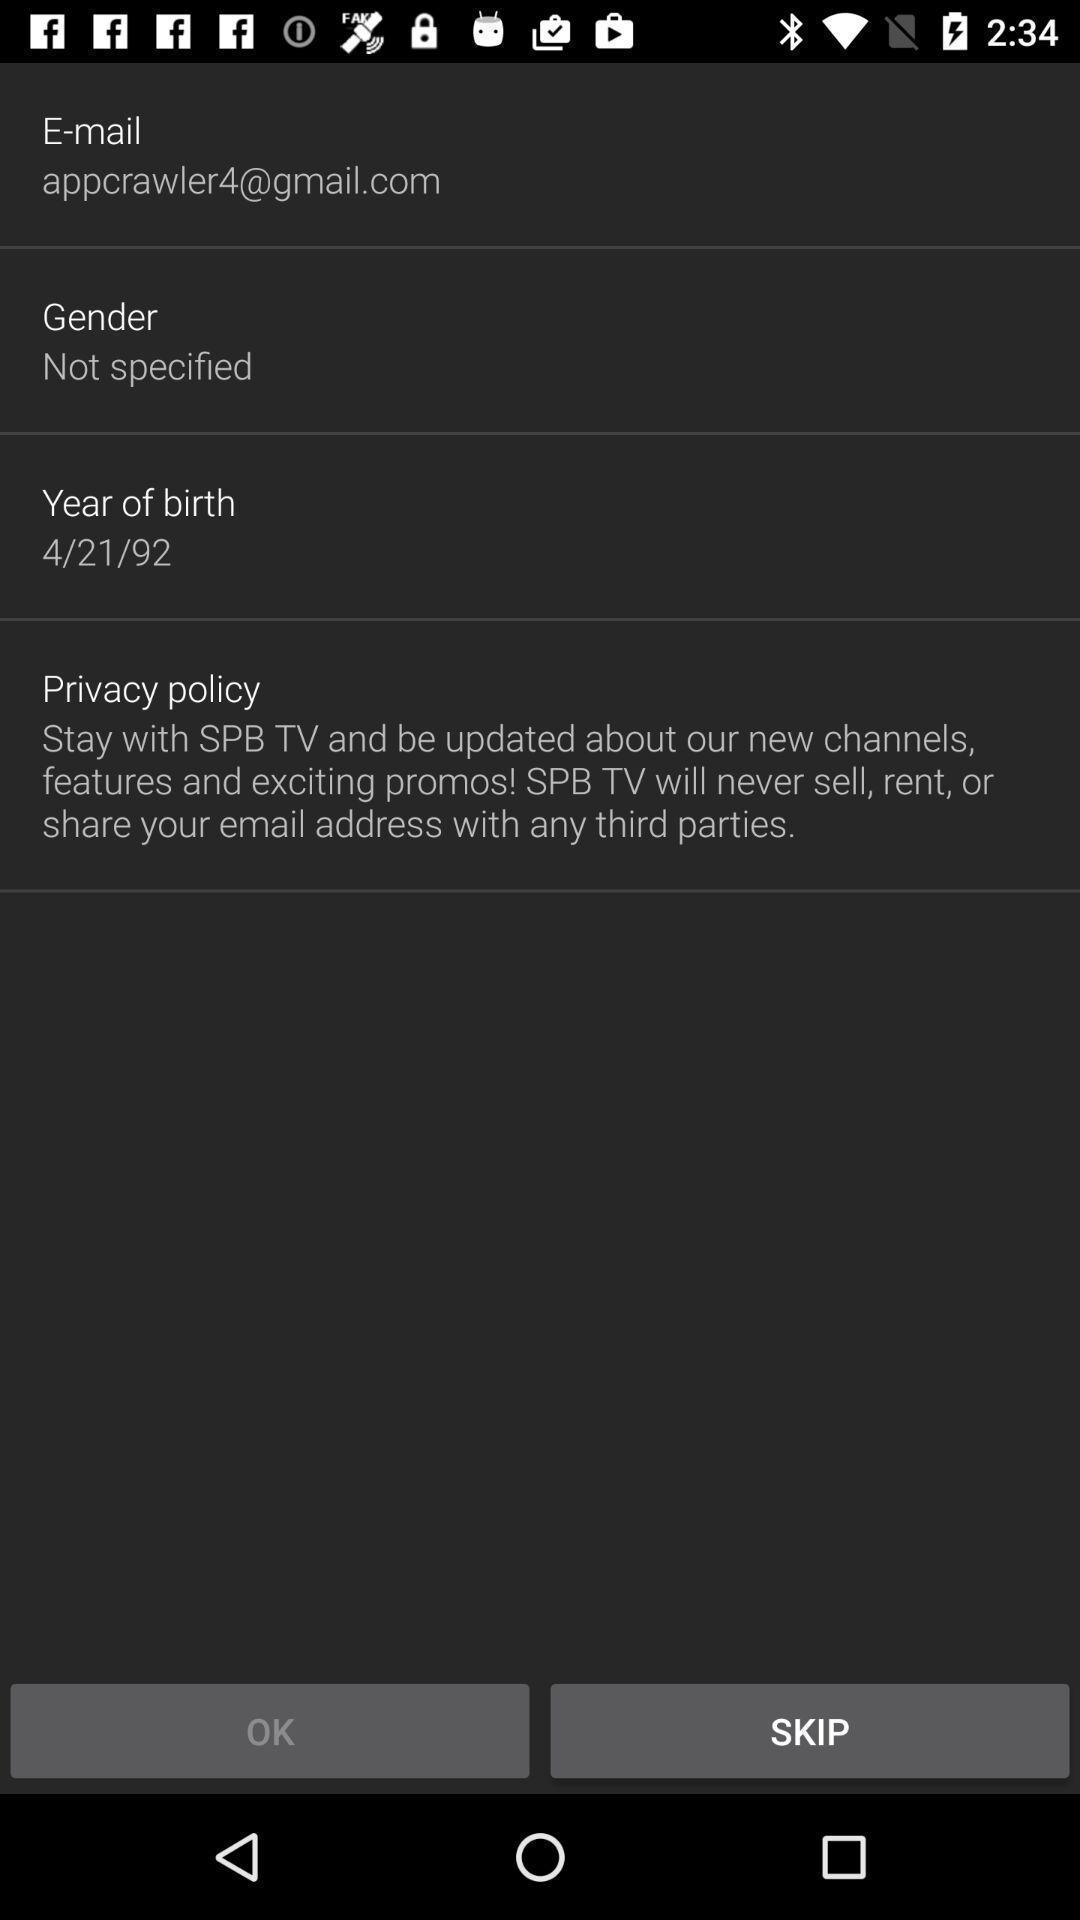Provide a description of this screenshot. Screen showing details with skip option. 